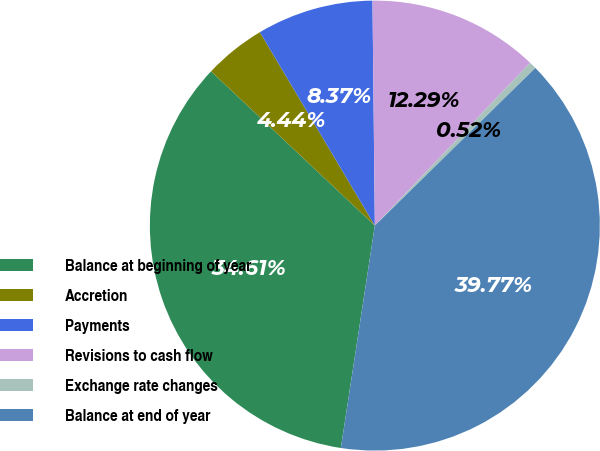Convert chart to OTSL. <chart><loc_0><loc_0><loc_500><loc_500><pie_chart><fcel>Balance at beginning of year<fcel>Accretion<fcel>Payments<fcel>Revisions to cash flow<fcel>Exchange rate changes<fcel>Balance at end of year<nl><fcel>34.61%<fcel>4.44%<fcel>8.37%<fcel>12.29%<fcel>0.52%<fcel>39.77%<nl></chart> 